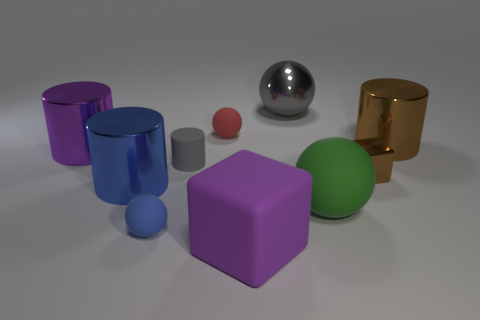Subtract all balls. How many objects are left? 6 Subtract 0 red blocks. How many objects are left? 10 Subtract all large purple matte objects. Subtract all brown metallic cylinders. How many objects are left? 8 Add 6 small brown metallic cubes. How many small brown metallic cubes are left? 7 Add 1 blue metal balls. How many blue metal balls exist? 1 